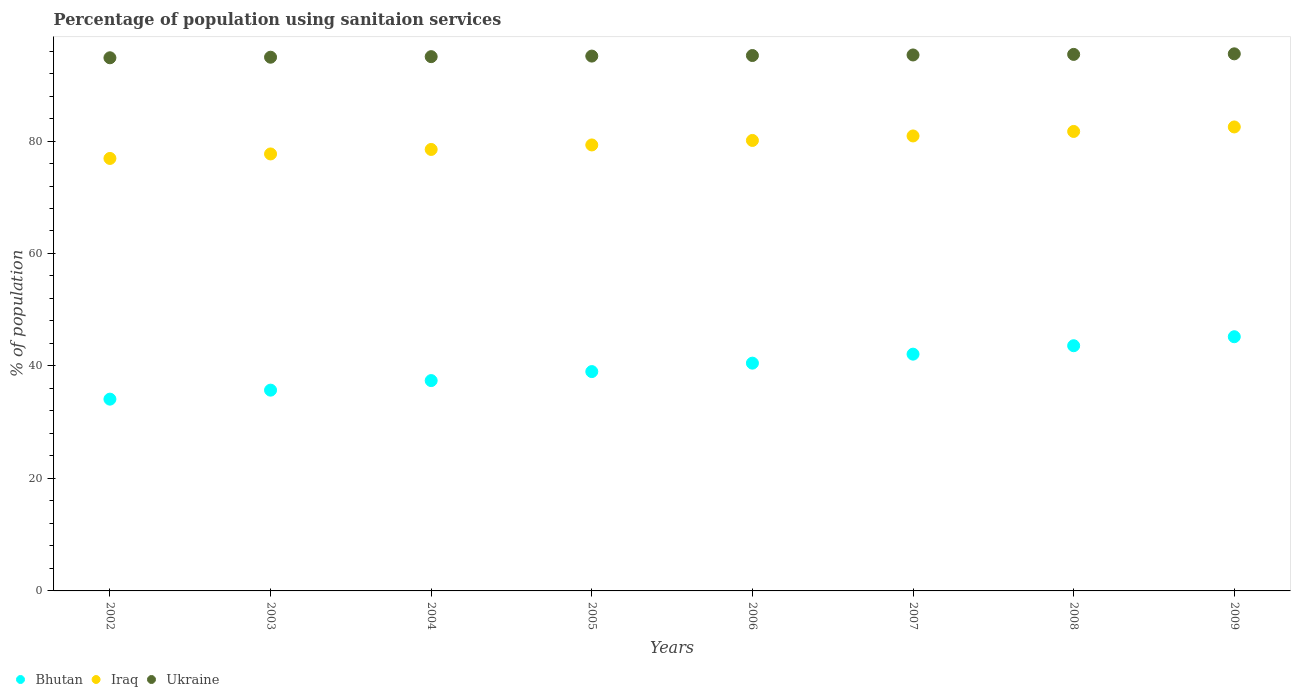Is the number of dotlines equal to the number of legend labels?
Keep it short and to the point. Yes. What is the percentage of population using sanitaion services in Ukraine in 2007?
Your answer should be very brief. 95.3. Across all years, what is the maximum percentage of population using sanitaion services in Ukraine?
Offer a very short reply. 95.5. Across all years, what is the minimum percentage of population using sanitaion services in Ukraine?
Make the answer very short. 94.8. In which year was the percentage of population using sanitaion services in Ukraine maximum?
Make the answer very short. 2009. What is the total percentage of population using sanitaion services in Bhutan in the graph?
Offer a very short reply. 317.6. What is the difference between the percentage of population using sanitaion services in Bhutan in 2004 and that in 2005?
Give a very brief answer. -1.6. What is the difference between the percentage of population using sanitaion services in Ukraine in 2002 and the percentage of population using sanitaion services in Bhutan in 2007?
Your answer should be compact. 52.7. What is the average percentage of population using sanitaion services in Bhutan per year?
Your response must be concise. 39.7. In the year 2009, what is the difference between the percentage of population using sanitaion services in Bhutan and percentage of population using sanitaion services in Ukraine?
Your answer should be compact. -50.3. What is the ratio of the percentage of population using sanitaion services in Bhutan in 2003 to that in 2007?
Give a very brief answer. 0.85. Is the percentage of population using sanitaion services in Bhutan in 2004 less than that in 2005?
Make the answer very short. Yes. What is the difference between the highest and the second highest percentage of population using sanitaion services in Ukraine?
Make the answer very short. 0.1. What is the difference between the highest and the lowest percentage of population using sanitaion services in Iraq?
Provide a succinct answer. 5.6. In how many years, is the percentage of population using sanitaion services in Bhutan greater than the average percentage of population using sanitaion services in Bhutan taken over all years?
Give a very brief answer. 4. Is it the case that in every year, the sum of the percentage of population using sanitaion services in Iraq and percentage of population using sanitaion services in Ukraine  is greater than the percentage of population using sanitaion services in Bhutan?
Provide a short and direct response. Yes. Does the percentage of population using sanitaion services in Iraq monotonically increase over the years?
Give a very brief answer. Yes. Is the percentage of population using sanitaion services in Bhutan strictly greater than the percentage of population using sanitaion services in Ukraine over the years?
Make the answer very short. No. Is the percentage of population using sanitaion services in Ukraine strictly less than the percentage of population using sanitaion services in Iraq over the years?
Your answer should be very brief. No. Does the graph contain any zero values?
Your answer should be compact. No. How are the legend labels stacked?
Your response must be concise. Horizontal. What is the title of the graph?
Your answer should be very brief. Percentage of population using sanitaion services. Does "Argentina" appear as one of the legend labels in the graph?
Provide a short and direct response. No. What is the label or title of the X-axis?
Provide a short and direct response. Years. What is the label or title of the Y-axis?
Provide a short and direct response. % of population. What is the % of population in Bhutan in 2002?
Make the answer very short. 34.1. What is the % of population of Iraq in 2002?
Give a very brief answer. 76.9. What is the % of population of Ukraine in 2002?
Provide a short and direct response. 94.8. What is the % of population of Bhutan in 2003?
Your answer should be very brief. 35.7. What is the % of population in Iraq in 2003?
Ensure brevity in your answer.  77.7. What is the % of population of Ukraine in 2003?
Offer a very short reply. 94.9. What is the % of population of Bhutan in 2004?
Your answer should be very brief. 37.4. What is the % of population of Iraq in 2004?
Your response must be concise. 78.5. What is the % of population in Ukraine in 2004?
Your answer should be very brief. 95. What is the % of population of Bhutan in 2005?
Offer a very short reply. 39. What is the % of population of Iraq in 2005?
Offer a very short reply. 79.3. What is the % of population in Ukraine in 2005?
Provide a succinct answer. 95.1. What is the % of population of Bhutan in 2006?
Offer a very short reply. 40.5. What is the % of population of Iraq in 2006?
Provide a succinct answer. 80.1. What is the % of population in Ukraine in 2006?
Provide a succinct answer. 95.2. What is the % of population of Bhutan in 2007?
Keep it short and to the point. 42.1. What is the % of population in Iraq in 2007?
Make the answer very short. 80.9. What is the % of population of Ukraine in 2007?
Offer a terse response. 95.3. What is the % of population of Bhutan in 2008?
Provide a short and direct response. 43.6. What is the % of population of Iraq in 2008?
Offer a terse response. 81.7. What is the % of population of Ukraine in 2008?
Offer a terse response. 95.4. What is the % of population of Bhutan in 2009?
Provide a succinct answer. 45.2. What is the % of population of Iraq in 2009?
Ensure brevity in your answer.  82.5. What is the % of population in Ukraine in 2009?
Make the answer very short. 95.5. Across all years, what is the maximum % of population of Bhutan?
Your answer should be compact. 45.2. Across all years, what is the maximum % of population in Iraq?
Your response must be concise. 82.5. Across all years, what is the maximum % of population in Ukraine?
Offer a very short reply. 95.5. Across all years, what is the minimum % of population of Bhutan?
Your answer should be very brief. 34.1. Across all years, what is the minimum % of population of Iraq?
Make the answer very short. 76.9. Across all years, what is the minimum % of population of Ukraine?
Ensure brevity in your answer.  94.8. What is the total % of population in Bhutan in the graph?
Your answer should be very brief. 317.6. What is the total % of population of Iraq in the graph?
Ensure brevity in your answer.  637.6. What is the total % of population of Ukraine in the graph?
Offer a very short reply. 761.2. What is the difference between the % of population of Iraq in 2002 and that in 2004?
Ensure brevity in your answer.  -1.6. What is the difference between the % of population of Ukraine in 2002 and that in 2004?
Provide a short and direct response. -0.2. What is the difference between the % of population of Bhutan in 2002 and that in 2005?
Provide a short and direct response. -4.9. What is the difference between the % of population of Iraq in 2002 and that in 2005?
Make the answer very short. -2.4. What is the difference between the % of population of Ukraine in 2002 and that in 2005?
Offer a very short reply. -0.3. What is the difference between the % of population of Ukraine in 2002 and that in 2006?
Give a very brief answer. -0.4. What is the difference between the % of population in Bhutan in 2002 and that in 2007?
Your response must be concise. -8. What is the difference between the % of population of Iraq in 2002 and that in 2007?
Your answer should be compact. -4. What is the difference between the % of population in Ukraine in 2002 and that in 2008?
Your answer should be compact. -0.6. What is the difference between the % of population in Bhutan in 2002 and that in 2009?
Provide a succinct answer. -11.1. What is the difference between the % of population in Iraq in 2002 and that in 2009?
Ensure brevity in your answer.  -5.6. What is the difference between the % of population in Ukraine in 2002 and that in 2009?
Your answer should be compact. -0.7. What is the difference between the % of population in Ukraine in 2003 and that in 2004?
Make the answer very short. -0.1. What is the difference between the % of population of Ukraine in 2003 and that in 2005?
Your response must be concise. -0.2. What is the difference between the % of population in Iraq in 2003 and that in 2006?
Offer a terse response. -2.4. What is the difference between the % of population in Bhutan in 2003 and that in 2007?
Your response must be concise. -6.4. What is the difference between the % of population in Ukraine in 2003 and that in 2007?
Provide a short and direct response. -0.4. What is the difference between the % of population of Iraq in 2003 and that in 2008?
Your response must be concise. -4. What is the difference between the % of population in Ukraine in 2003 and that in 2008?
Make the answer very short. -0.5. What is the difference between the % of population of Ukraine in 2003 and that in 2009?
Provide a short and direct response. -0.6. What is the difference between the % of population in Bhutan in 2004 and that in 2005?
Offer a very short reply. -1.6. What is the difference between the % of population of Ukraine in 2004 and that in 2005?
Provide a short and direct response. -0.1. What is the difference between the % of population of Bhutan in 2004 and that in 2006?
Your answer should be compact. -3.1. What is the difference between the % of population of Iraq in 2004 and that in 2006?
Offer a very short reply. -1.6. What is the difference between the % of population in Iraq in 2004 and that in 2007?
Offer a terse response. -2.4. What is the difference between the % of population of Iraq in 2004 and that in 2008?
Your response must be concise. -3.2. What is the difference between the % of population of Bhutan in 2004 and that in 2009?
Provide a succinct answer. -7.8. What is the difference between the % of population of Bhutan in 2005 and that in 2006?
Ensure brevity in your answer.  -1.5. What is the difference between the % of population of Iraq in 2005 and that in 2006?
Your answer should be very brief. -0.8. What is the difference between the % of population in Bhutan in 2005 and that in 2007?
Provide a succinct answer. -3.1. What is the difference between the % of population in Iraq in 2005 and that in 2007?
Give a very brief answer. -1.6. What is the difference between the % of population of Ukraine in 2005 and that in 2007?
Offer a terse response. -0.2. What is the difference between the % of population of Bhutan in 2005 and that in 2008?
Make the answer very short. -4.6. What is the difference between the % of population in Iraq in 2005 and that in 2008?
Provide a succinct answer. -2.4. What is the difference between the % of population in Iraq in 2005 and that in 2009?
Ensure brevity in your answer.  -3.2. What is the difference between the % of population in Iraq in 2006 and that in 2007?
Provide a succinct answer. -0.8. What is the difference between the % of population in Bhutan in 2006 and that in 2008?
Provide a succinct answer. -3.1. What is the difference between the % of population in Iraq in 2006 and that in 2009?
Your answer should be compact. -2.4. What is the difference between the % of population in Iraq in 2007 and that in 2009?
Provide a succinct answer. -1.6. What is the difference between the % of population of Ukraine in 2007 and that in 2009?
Offer a very short reply. -0.2. What is the difference between the % of population in Bhutan in 2008 and that in 2009?
Your response must be concise. -1.6. What is the difference between the % of population in Iraq in 2008 and that in 2009?
Provide a succinct answer. -0.8. What is the difference between the % of population of Ukraine in 2008 and that in 2009?
Provide a short and direct response. -0.1. What is the difference between the % of population of Bhutan in 2002 and the % of population of Iraq in 2003?
Your answer should be compact. -43.6. What is the difference between the % of population in Bhutan in 2002 and the % of population in Ukraine in 2003?
Ensure brevity in your answer.  -60.8. What is the difference between the % of population in Bhutan in 2002 and the % of population in Iraq in 2004?
Offer a very short reply. -44.4. What is the difference between the % of population of Bhutan in 2002 and the % of population of Ukraine in 2004?
Your answer should be very brief. -60.9. What is the difference between the % of population in Iraq in 2002 and the % of population in Ukraine in 2004?
Your answer should be very brief. -18.1. What is the difference between the % of population of Bhutan in 2002 and the % of population of Iraq in 2005?
Give a very brief answer. -45.2. What is the difference between the % of population of Bhutan in 2002 and the % of population of Ukraine in 2005?
Give a very brief answer. -61. What is the difference between the % of population in Iraq in 2002 and the % of population in Ukraine in 2005?
Provide a succinct answer. -18.2. What is the difference between the % of population of Bhutan in 2002 and the % of population of Iraq in 2006?
Offer a terse response. -46. What is the difference between the % of population of Bhutan in 2002 and the % of population of Ukraine in 2006?
Ensure brevity in your answer.  -61.1. What is the difference between the % of population of Iraq in 2002 and the % of population of Ukraine in 2006?
Give a very brief answer. -18.3. What is the difference between the % of population of Bhutan in 2002 and the % of population of Iraq in 2007?
Offer a very short reply. -46.8. What is the difference between the % of population in Bhutan in 2002 and the % of population in Ukraine in 2007?
Make the answer very short. -61.2. What is the difference between the % of population of Iraq in 2002 and the % of population of Ukraine in 2007?
Your answer should be compact. -18.4. What is the difference between the % of population of Bhutan in 2002 and the % of population of Iraq in 2008?
Keep it short and to the point. -47.6. What is the difference between the % of population of Bhutan in 2002 and the % of population of Ukraine in 2008?
Your answer should be compact. -61.3. What is the difference between the % of population of Iraq in 2002 and the % of population of Ukraine in 2008?
Your answer should be very brief. -18.5. What is the difference between the % of population in Bhutan in 2002 and the % of population in Iraq in 2009?
Give a very brief answer. -48.4. What is the difference between the % of population of Bhutan in 2002 and the % of population of Ukraine in 2009?
Make the answer very short. -61.4. What is the difference between the % of population of Iraq in 2002 and the % of population of Ukraine in 2009?
Your response must be concise. -18.6. What is the difference between the % of population of Bhutan in 2003 and the % of population of Iraq in 2004?
Your answer should be compact. -42.8. What is the difference between the % of population in Bhutan in 2003 and the % of population in Ukraine in 2004?
Your answer should be compact. -59.3. What is the difference between the % of population of Iraq in 2003 and the % of population of Ukraine in 2004?
Your answer should be compact. -17.3. What is the difference between the % of population of Bhutan in 2003 and the % of population of Iraq in 2005?
Make the answer very short. -43.6. What is the difference between the % of population in Bhutan in 2003 and the % of population in Ukraine in 2005?
Offer a very short reply. -59.4. What is the difference between the % of population in Iraq in 2003 and the % of population in Ukraine in 2005?
Keep it short and to the point. -17.4. What is the difference between the % of population in Bhutan in 2003 and the % of population in Iraq in 2006?
Provide a succinct answer. -44.4. What is the difference between the % of population of Bhutan in 2003 and the % of population of Ukraine in 2006?
Keep it short and to the point. -59.5. What is the difference between the % of population in Iraq in 2003 and the % of population in Ukraine in 2006?
Offer a very short reply. -17.5. What is the difference between the % of population of Bhutan in 2003 and the % of population of Iraq in 2007?
Make the answer very short. -45.2. What is the difference between the % of population in Bhutan in 2003 and the % of population in Ukraine in 2007?
Provide a succinct answer. -59.6. What is the difference between the % of population of Iraq in 2003 and the % of population of Ukraine in 2007?
Your answer should be compact. -17.6. What is the difference between the % of population in Bhutan in 2003 and the % of population in Iraq in 2008?
Keep it short and to the point. -46. What is the difference between the % of population of Bhutan in 2003 and the % of population of Ukraine in 2008?
Your answer should be very brief. -59.7. What is the difference between the % of population of Iraq in 2003 and the % of population of Ukraine in 2008?
Make the answer very short. -17.7. What is the difference between the % of population of Bhutan in 2003 and the % of population of Iraq in 2009?
Offer a very short reply. -46.8. What is the difference between the % of population in Bhutan in 2003 and the % of population in Ukraine in 2009?
Provide a short and direct response. -59.8. What is the difference between the % of population in Iraq in 2003 and the % of population in Ukraine in 2009?
Offer a terse response. -17.8. What is the difference between the % of population of Bhutan in 2004 and the % of population of Iraq in 2005?
Give a very brief answer. -41.9. What is the difference between the % of population of Bhutan in 2004 and the % of population of Ukraine in 2005?
Provide a short and direct response. -57.7. What is the difference between the % of population in Iraq in 2004 and the % of population in Ukraine in 2005?
Keep it short and to the point. -16.6. What is the difference between the % of population in Bhutan in 2004 and the % of population in Iraq in 2006?
Provide a succinct answer. -42.7. What is the difference between the % of population of Bhutan in 2004 and the % of population of Ukraine in 2006?
Provide a succinct answer. -57.8. What is the difference between the % of population of Iraq in 2004 and the % of population of Ukraine in 2006?
Provide a succinct answer. -16.7. What is the difference between the % of population in Bhutan in 2004 and the % of population in Iraq in 2007?
Your response must be concise. -43.5. What is the difference between the % of population in Bhutan in 2004 and the % of population in Ukraine in 2007?
Provide a succinct answer. -57.9. What is the difference between the % of population of Iraq in 2004 and the % of population of Ukraine in 2007?
Keep it short and to the point. -16.8. What is the difference between the % of population of Bhutan in 2004 and the % of population of Iraq in 2008?
Provide a succinct answer. -44.3. What is the difference between the % of population of Bhutan in 2004 and the % of population of Ukraine in 2008?
Your response must be concise. -58. What is the difference between the % of population of Iraq in 2004 and the % of population of Ukraine in 2008?
Make the answer very short. -16.9. What is the difference between the % of population of Bhutan in 2004 and the % of population of Iraq in 2009?
Your response must be concise. -45.1. What is the difference between the % of population of Bhutan in 2004 and the % of population of Ukraine in 2009?
Provide a short and direct response. -58.1. What is the difference between the % of population in Bhutan in 2005 and the % of population in Iraq in 2006?
Provide a short and direct response. -41.1. What is the difference between the % of population of Bhutan in 2005 and the % of population of Ukraine in 2006?
Provide a succinct answer. -56.2. What is the difference between the % of population in Iraq in 2005 and the % of population in Ukraine in 2006?
Keep it short and to the point. -15.9. What is the difference between the % of population of Bhutan in 2005 and the % of population of Iraq in 2007?
Give a very brief answer. -41.9. What is the difference between the % of population of Bhutan in 2005 and the % of population of Ukraine in 2007?
Give a very brief answer. -56.3. What is the difference between the % of population of Iraq in 2005 and the % of population of Ukraine in 2007?
Your answer should be very brief. -16. What is the difference between the % of population of Bhutan in 2005 and the % of population of Iraq in 2008?
Offer a terse response. -42.7. What is the difference between the % of population of Bhutan in 2005 and the % of population of Ukraine in 2008?
Offer a terse response. -56.4. What is the difference between the % of population of Iraq in 2005 and the % of population of Ukraine in 2008?
Ensure brevity in your answer.  -16.1. What is the difference between the % of population of Bhutan in 2005 and the % of population of Iraq in 2009?
Ensure brevity in your answer.  -43.5. What is the difference between the % of population of Bhutan in 2005 and the % of population of Ukraine in 2009?
Offer a very short reply. -56.5. What is the difference between the % of population in Iraq in 2005 and the % of population in Ukraine in 2009?
Keep it short and to the point. -16.2. What is the difference between the % of population of Bhutan in 2006 and the % of population of Iraq in 2007?
Give a very brief answer. -40.4. What is the difference between the % of population of Bhutan in 2006 and the % of population of Ukraine in 2007?
Offer a very short reply. -54.8. What is the difference between the % of population of Iraq in 2006 and the % of population of Ukraine in 2007?
Your answer should be very brief. -15.2. What is the difference between the % of population of Bhutan in 2006 and the % of population of Iraq in 2008?
Give a very brief answer. -41.2. What is the difference between the % of population in Bhutan in 2006 and the % of population in Ukraine in 2008?
Give a very brief answer. -54.9. What is the difference between the % of population of Iraq in 2006 and the % of population of Ukraine in 2008?
Offer a terse response. -15.3. What is the difference between the % of population of Bhutan in 2006 and the % of population of Iraq in 2009?
Give a very brief answer. -42. What is the difference between the % of population in Bhutan in 2006 and the % of population in Ukraine in 2009?
Your answer should be very brief. -55. What is the difference between the % of population of Iraq in 2006 and the % of population of Ukraine in 2009?
Your answer should be compact. -15.4. What is the difference between the % of population in Bhutan in 2007 and the % of population in Iraq in 2008?
Make the answer very short. -39.6. What is the difference between the % of population in Bhutan in 2007 and the % of population in Ukraine in 2008?
Ensure brevity in your answer.  -53.3. What is the difference between the % of population of Iraq in 2007 and the % of population of Ukraine in 2008?
Provide a short and direct response. -14.5. What is the difference between the % of population in Bhutan in 2007 and the % of population in Iraq in 2009?
Provide a short and direct response. -40.4. What is the difference between the % of population in Bhutan in 2007 and the % of population in Ukraine in 2009?
Provide a short and direct response. -53.4. What is the difference between the % of population of Iraq in 2007 and the % of population of Ukraine in 2009?
Provide a short and direct response. -14.6. What is the difference between the % of population in Bhutan in 2008 and the % of population in Iraq in 2009?
Your answer should be very brief. -38.9. What is the difference between the % of population in Bhutan in 2008 and the % of population in Ukraine in 2009?
Ensure brevity in your answer.  -51.9. What is the average % of population of Bhutan per year?
Your answer should be very brief. 39.7. What is the average % of population in Iraq per year?
Your answer should be very brief. 79.7. What is the average % of population of Ukraine per year?
Provide a succinct answer. 95.15. In the year 2002, what is the difference between the % of population of Bhutan and % of population of Iraq?
Keep it short and to the point. -42.8. In the year 2002, what is the difference between the % of population in Bhutan and % of population in Ukraine?
Make the answer very short. -60.7. In the year 2002, what is the difference between the % of population of Iraq and % of population of Ukraine?
Offer a very short reply. -17.9. In the year 2003, what is the difference between the % of population of Bhutan and % of population of Iraq?
Give a very brief answer. -42. In the year 2003, what is the difference between the % of population of Bhutan and % of population of Ukraine?
Offer a terse response. -59.2. In the year 2003, what is the difference between the % of population of Iraq and % of population of Ukraine?
Offer a very short reply. -17.2. In the year 2004, what is the difference between the % of population of Bhutan and % of population of Iraq?
Ensure brevity in your answer.  -41.1. In the year 2004, what is the difference between the % of population in Bhutan and % of population in Ukraine?
Your answer should be very brief. -57.6. In the year 2004, what is the difference between the % of population of Iraq and % of population of Ukraine?
Make the answer very short. -16.5. In the year 2005, what is the difference between the % of population of Bhutan and % of population of Iraq?
Your answer should be compact. -40.3. In the year 2005, what is the difference between the % of population of Bhutan and % of population of Ukraine?
Your response must be concise. -56.1. In the year 2005, what is the difference between the % of population in Iraq and % of population in Ukraine?
Offer a terse response. -15.8. In the year 2006, what is the difference between the % of population of Bhutan and % of population of Iraq?
Your answer should be compact. -39.6. In the year 2006, what is the difference between the % of population in Bhutan and % of population in Ukraine?
Ensure brevity in your answer.  -54.7. In the year 2006, what is the difference between the % of population in Iraq and % of population in Ukraine?
Ensure brevity in your answer.  -15.1. In the year 2007, what is the difference between the % of population in Bhutan and % of population in Iraq?
Give a very brief answer. -38.8. In the year 2007, what is the difference between the % of population in Bhutan and % of population in Ukraine?
Your answer should be compact. -53.2. In the year 2007, what is the difference between the % of population in Iraq and % of population in Ukraine?
Your response must be concise. -14.4. In the year 2008, what is the difference between the % of population of Bhutan and % of population of Iraq?
Offer a terse response. -38.1. In the year 2008, what is the difference between the % of population in Bhutan and % of population in Ukraine?
Keep it short and to the point. -51.8. In the year 2008, what is the difference between the % of population of Iraq and % of population of Ukraine?
Your response must be concise. -13.7. In the year 2009, what is the difference between the % of population of Bhutan and % of population of Iraq?
Keep it short and to the point. -37.3. In the year 2009, what is the difference between the % of population in Bhutan and % of population in Ukraine?
Your answer should be very brief. -50.3. In the year 2009, what is the difference between the % of population of Iraq and % of population of Ukraine?
Ensure brevity in your answer.  -13. What is the ratio of the % of population in Bhutan in 2002 to that in 2003?
Your answer should be compact. 0.96. What is the ratio of the % of population of Iraq in 2002 to that in 2003?
Offer a very short reply. 0.99. What is the ratio of the % of population of Bhutan in 2002 to that in 2004?
Ensure brevity in your answer.  0.91. What is the ratio of the % of population of Iraq in 2002 to that in 2004?
Give a very brief answer. 0.98. What is the ratio of the % of population in Bhutan in 2002 to that in 2005?
Keep it short and to the point. 0.87. What is the ratio of the % of population in Iraq in 2002 to that in 2005?
Keep it short and to the point. 0.97. What is the ratio of the % of population of Bhutan in 2002 to that in 2006?
Offer a terse response. 0.84. What is the ratio of the % of population in Iraq in 2002 to that in 2006?
Keep it short and to the point. 0.96. What is the ratio of the % of population in Ukraine in 2002 to that in 2006?
Keep it short and to the point. 1. What is the ratio of the % of population in Bhutan in 2002 to that in 2007?
Your answer should be very brief. 0.81. What is the ratio of the % of population of Iraq in 2002 to that in 2007?
Give a very brief answer. 0.95. What is the ratio of the % of population of Ukraine in 2002 to that in 2007?
Give a very brief answer. 0.99. What is the ratio of the % of population of Bhutan in 2002 to that in 2008?
Keep it short and to the point. 0.78. What is the ratio of the % of population in Bhutan in 2002 to that in 2009?
Keep it short and to the point. 0.75. What is the ratio of the % of population in Iraq in 2002 to that in 2009?
Your answer should be compact. 0.93. What is the ratio of the % of population of Bhutan in 2003 to that in 2004?
Your response must be concise. 0.95. What is the ratio of the % of population of Ukraine in 2003 to that in 2004?
Give a very brief answer. 1. What is the ratio of the % of population in Bhutan in 2003 to that in 2005?
Your answer should be compact. 0.92. What is the ratio of the % of population of Iraq in 2003 to that in 2005?
Make the answer very short. 0.98. What is the ratio of the % of population of Bhutan in 2003 to that in 2006?
Your response must be concise. 0.88. What is the ratio of the % of population in Ukraine in 2003 to that in 2006?
Give a very brief answer. 1. What is the ratio of the % of population of Bhutan in 2003 to that in 2007?
Make the answer very short. 0.85. What is the ratio of the % of population in Iraq in 2003 to that in 2007?
Give a very brief answer. 0.96. What is the ratio of the % of population of Ukraine in 2003 to that in 2007?
Give a very brief answer. 1. What is the ratio of the % of population in Bhutan in 2003 to that in 2008?
Provide a succinct answer. 0.82. What is the ratio of the % of population of Iraq in 2003 to that in 2008?
Provide a short and direct response. 0.95. What is the ratio of the % of population of Bhutan in 2003 to that in 2009?
Offer a terse response. 0.79. What is the ratio of the % of population in Iraq in 2003 to that in 2009?
Offer a very short reply. 0.94. What is the ratio of the % of population of Ukraine in 2003 to that in 2009?
Provide a succinct answer. 0.99. What is the ratio of the % of population of Iraq in 2004 to that in 2005?
Your answer should be very brief. 0.99. What is the ratio of the % of population in Ukraine in 2004 to that in 2005?
Provide a short and direct response. 1. What is the ratio of the % of population of Bhutan in 2004 to that in 2006?
Your answer should be compact. 0.92. What is the ratio of the % of population of Bhutan in 2004 to that in 2007?
Give a very brief answer. 0.89. What is the ratio of the % of population in Iraq in 2004 to that in 2007?
Keep it short and to the point. 0.97. What is the ratio of the % of population in Ukraine in 2004 to that in 2007?
Your answer should be compact. 1. What is the ratio of the % of population of Bhutan in 2004 to that in 2008?
Offer a very short reply. 0.86. What is the ratio of the % of population of Iraq in 2004 to that in 2008?
Give a very brief answer. 0.96. What is the ratio of the % of population of Ukraine in 2004 to that in 2008?
Offer a terse response. 1. What is the ratio of the % of population of Bhutan in 2004 to that in 2009?
Ensure brevity in your answer.  0.83. What is the ratio of the % of population of Iraq in 2004 to that in 2009?
Ensure brevity in your answer.  0.95. What is the ratio of the % of population of Ukraine in 2004 to that in 2009?
Provide a short and direct response. 0.99. What is the ratio of the % of population of Iraq in 2005 to that in 2006?
Offer a terse response. 0.99. What is the ratio of the % of population in Ukraine in 2005 to that in 2006?
Give a very brief answer. 1. What is the ratio of the % of population of Bhutan in 2005 to that in 2007?
Offer a terse response. 0.93. What is the ratio of the % of population of Iraq in 2005 to that in 2007?
Offer a very short reply. 0.98. What is the ratio of the % of population in Bhutan in 2005 to that in 2008?
Your answer should be very brief. 0.89. What is the ratio of the % of population in Iraq in 2005 to that in 2008?
Keep it short and to the point. 0.97. What is the ratio of the % of population of Ukraine in 2005 to that in 2008?
Your response must be concise. 1. What is the ratio of the % of population in Bhutan in 2005 to that in 2009?
Give a very brief answer. 0.86. What is the ratio of the % of population in Iraq in 2005 to that in 2009?
Ensure brevity in your answer.  0.96. What is the ratio of the % of population in Ukraine in 2005 to that in 2009?
Give a very brief answer. 1. What is the ratio of the % of population in Bhutan in 2006 to that in 2008?
Make the answer very short. 0.93. What is the ratio of the % of population in Iraq in 2006 to that in 2008?
Offer a very short reply. 0.98. What is the ratio of the % of population of Bhutan in 2006 to that in 2009?
Give a very brief answer. 0.9. What is the ratio of the % of population in Iraq in 2006 to that in 2009?
Ensure brevity in your answer.  0.97. What is the ratio of the % of population in Bhutan in 2007 to that in 2008?
Offer a terse response. 0.97. What is the ratio of the % of population of Iraq in 2007 to that in 2008?
Ensure brevity in your answer.  0.99. What is the ratio of the % of population of Bhutan in 2007 to that in 2009?
Your answer should be very brief. 0.93. What is the ratio of the % of population in Iraq in 2007 to that in 2009?
Your answer should be compact. 0.98. What is the ratio of the % of population of Bhutan in 2008 to that in 2009?
Your response must be concise. 0.96. What is the ratio of the % of population in Iraq in 2008 to that in 2009?
Offer a very short reply. 0.99. What is the ratio of the % of population of Ukraine in 2008 to that in 2009?
Provide a short and direct response. 1. What is the difference between the highest and the second highest % of population in Bhutan?
Give a very brief answer. 1.6. What is the difference between the highest and the second highest % of population in Iraq?
Ensure brevity in your answer.  0.8. What is the difference between the highest and the second highest % of population of Ukraine?
Give a very brief answer. 0.1. What is the difference between the highest and the lowest % of population in Iraq?
Your response must be concise. 5.6. 